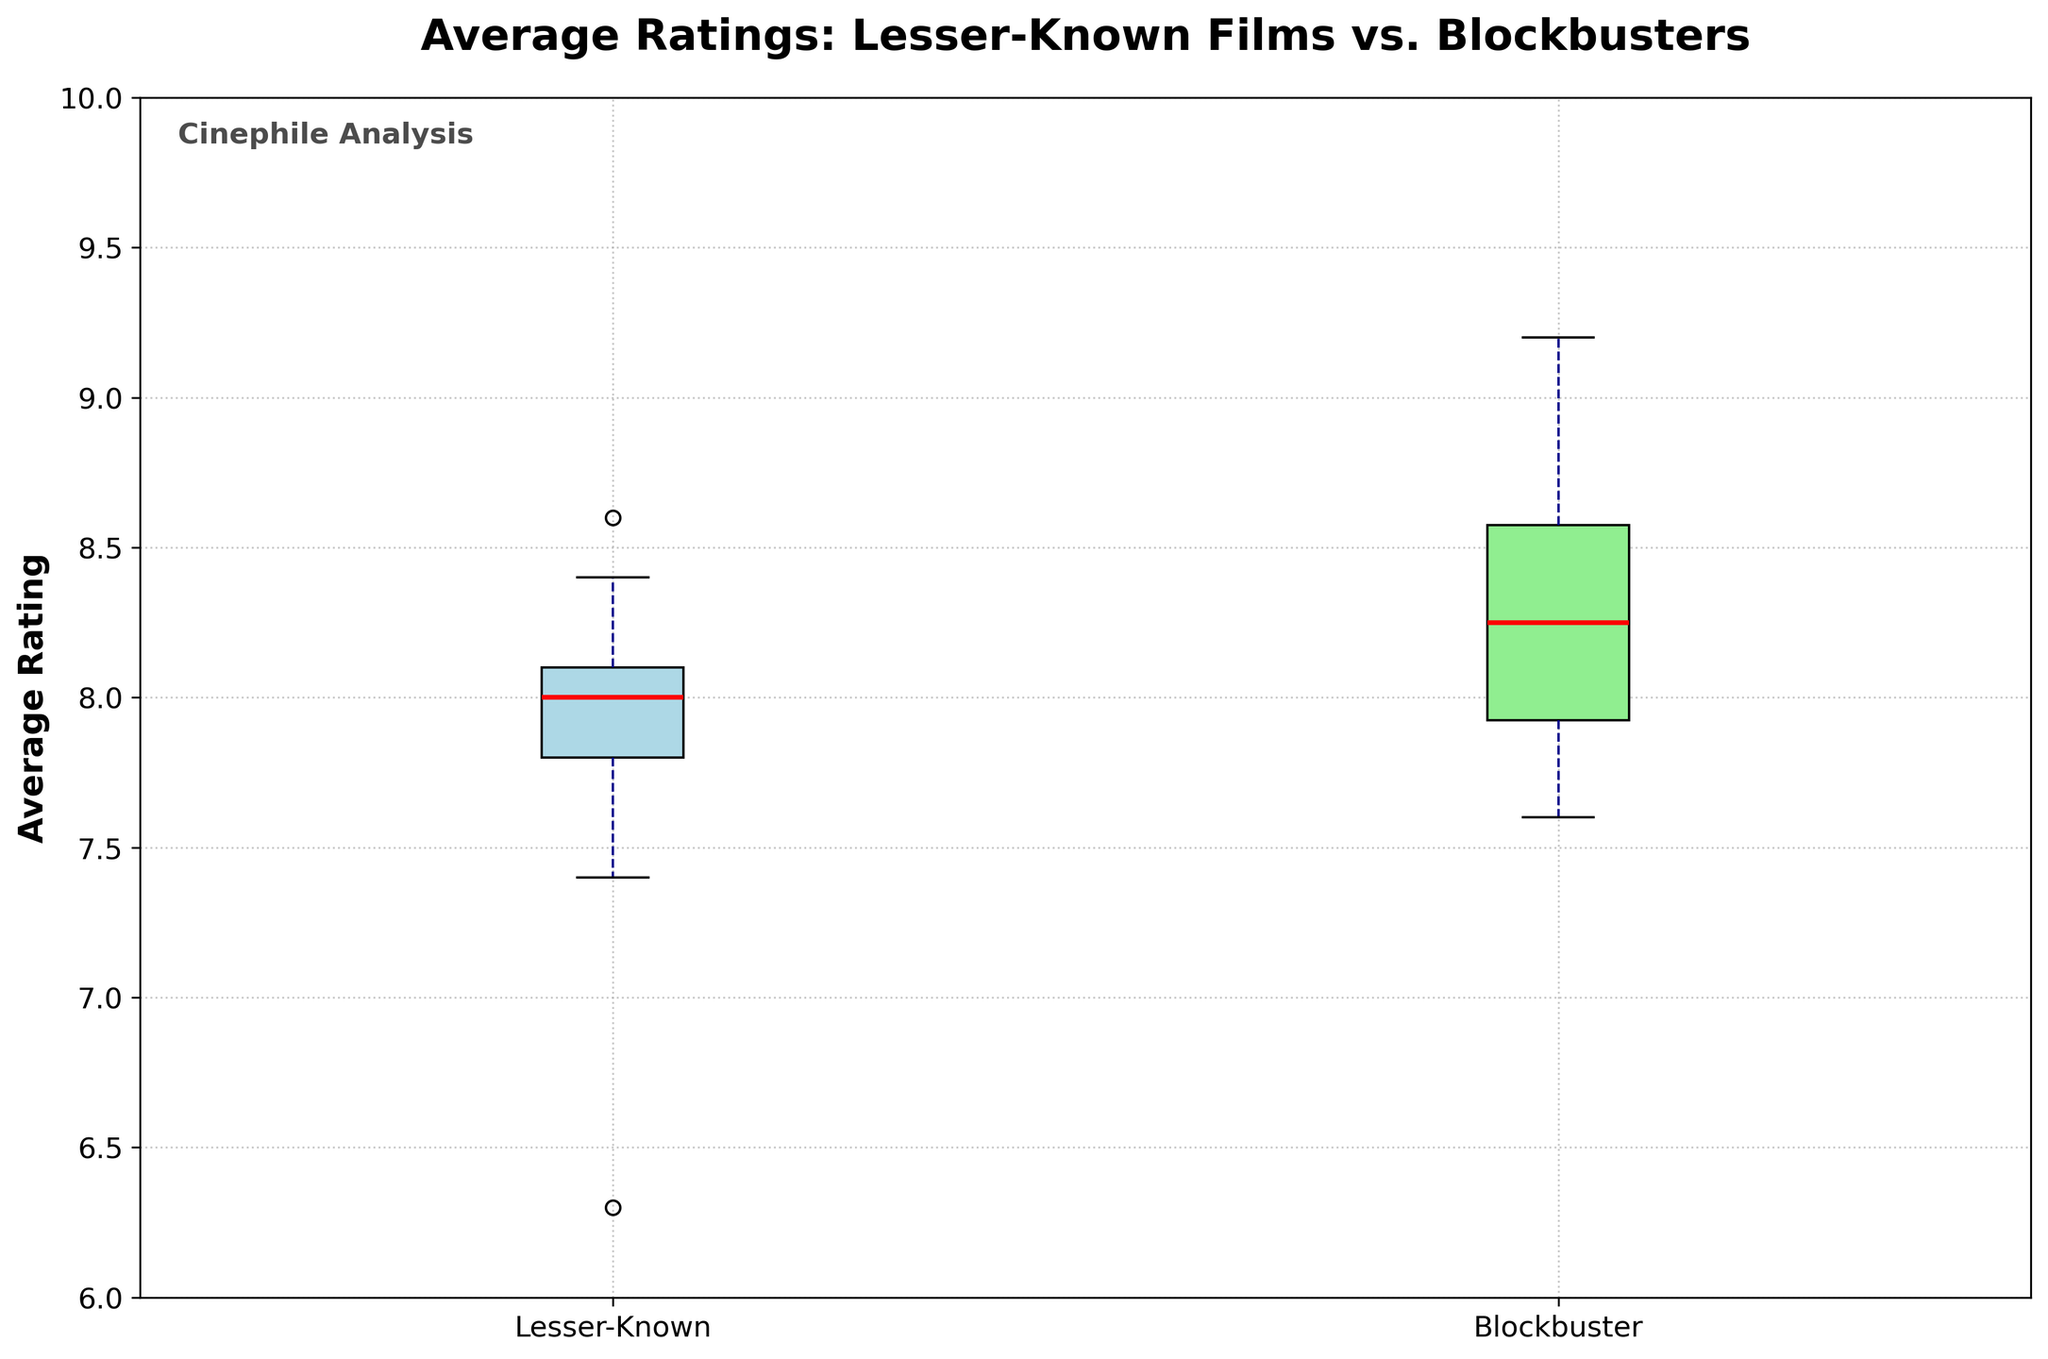What are the two types of films being compared in the plot? The plot compares the average ratings of "Lesser-Known" films and "Blockbuster" films. This information is indicated by the labels on the x-axis of the plot.
Answer: Lesser-Known and Blockbuster What is the range of the average ratings for blockbusters? The range of values can be observed by looking at the whiskers of the box plot for blockbusters, which shows the minimum and maximum ratings.
Answer: Approximately 7.5 to 9.0 What does the red line inside each box represent? In a box plot, the red line within each box indicates the median value of the data group, which is the middle value of the sorted data.
Answer: Median How does the median rating of lesser-known films compare to the median rating of blockbusters? By observing the red lines, the median rating for blockbuster films is higher than that for lesser-known films.
Answer: Blockbusters have a higher median What's the difference between the highest average ratings of the blockbusters and lesser-known films? The highest rating for blockbusters is around 9.0, and for lesser-known films, it's around 8.6. The difference is 9.0 - 8.6.
Answer: 0.4 Which type of film has a wider range of average ratings? To determine the wider range, look at the length of the whiskers for each type. Blockbusters have both higher maximum and lower minimum values compared to lesser-known films, indicating a wider range.
Answer: Blockbuster What decade might have contributed to the high median rating of blockbusters? By analyzing the individual ratings data, the 1970s have highly-rated blockbusters such as "The Godfather" (9.2) and "Star Wars" (8.6), which could contribute significantly to the high median rating.
Answer: 1970s Is there an outlier in the ratings for lesser-known films? While typical box plots can indicate outliers with specific markers, this box plot does not show any visibly separate points outside the whiskers for lesser-known films.
Answer: No What is the difference between the median ratings of blockbusters and lesser-known films? The median rating for blockbusters appears at around 8.0-8.2, and for lesser-known films, it is around 7.9. Thus, the difference is about 8.1 - 7.9.
Answer: 0.2 